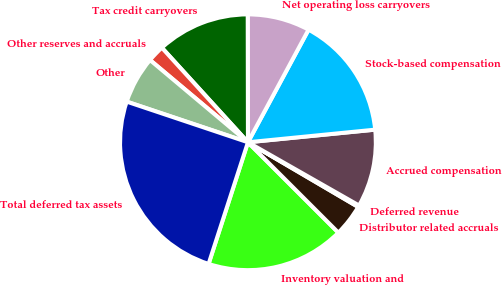Convert chart to OTSL. <chart><loc_0><loc_0><loc_500><loc_500><pie_chart><fcel>Inventory valuation and<fcel>Distributor related accruals<fcel>Deferred revenue<fcel>Accrued compensation<fcel>Stock-based compensation<fcel>Net operating loss carryovers<fcel>Tax credit carryovers<fcel>Other reserves and accruals<fcel>Other<fcel>Total deferred tax assets<nl><fcel>17.49%<fcel>4.05%<fcel>0.21%<fcel>9.81%<fcel>15.57%<fcel>7.89%<fcel>11.73%<fcel>2.13%<fcel>5.97%<fcel>25.17%<nl></chart> 